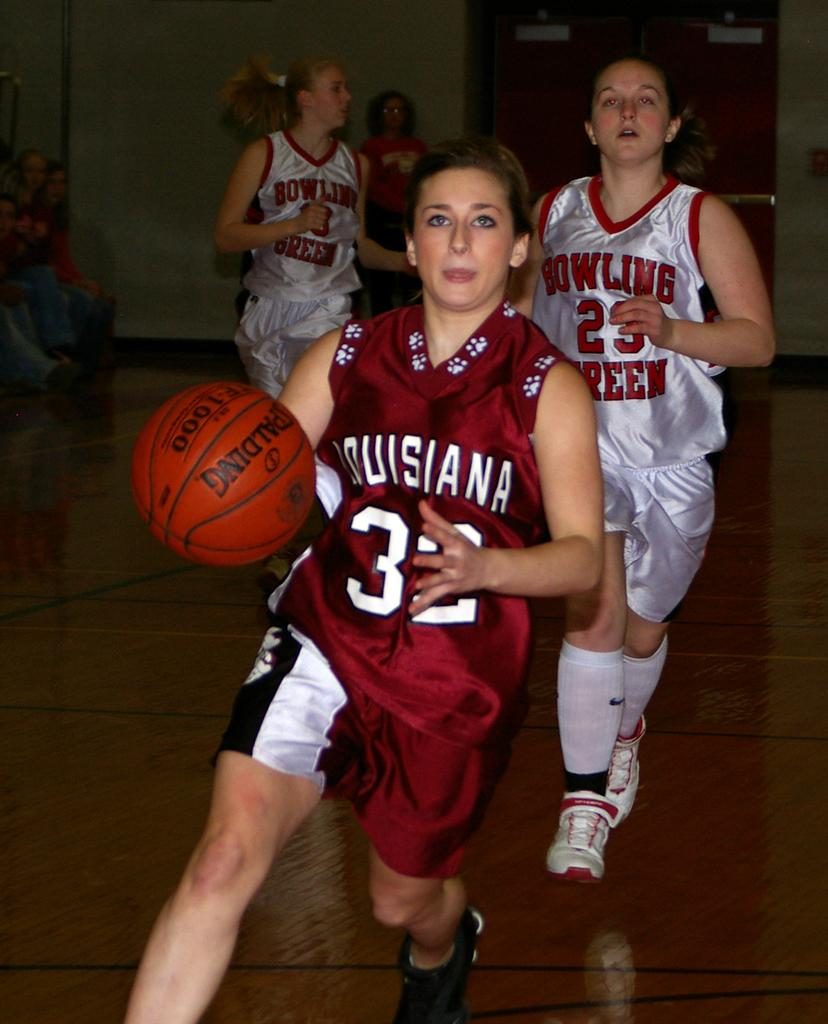<image>
Share a concise interpretation of the image provided. A female basket ball player in red with Louisiana on her shirt prepares to throw the ball whilst her opponent in white wearing 23 looks on 